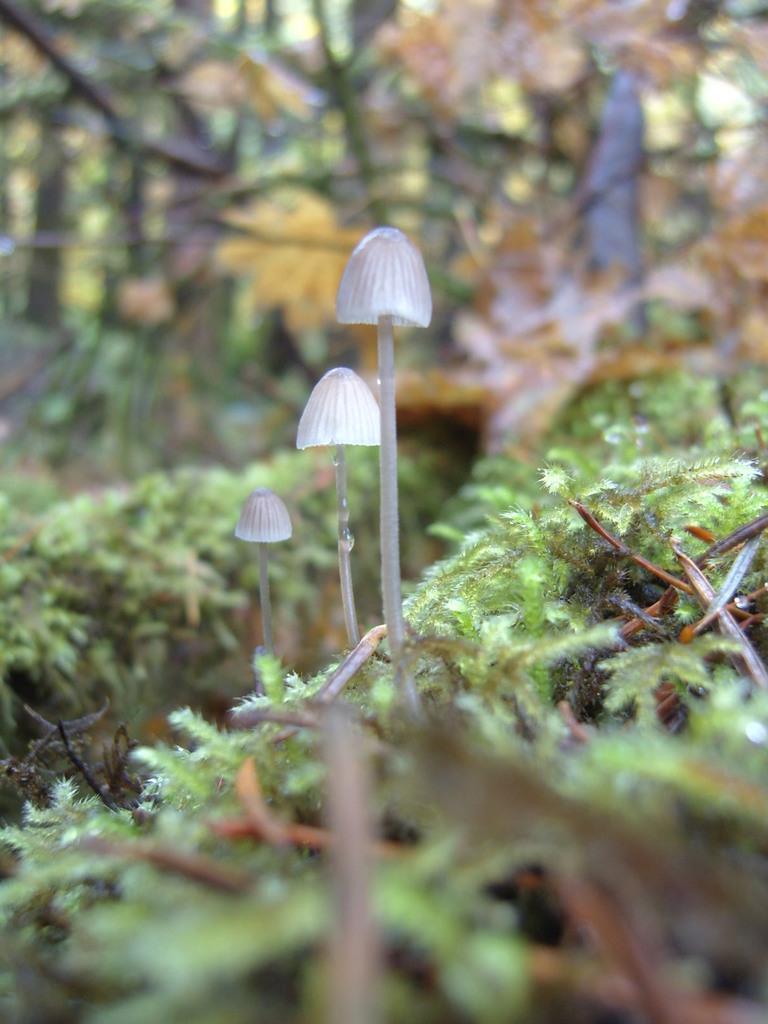Can you describe this image briefly? These are green color trees. 